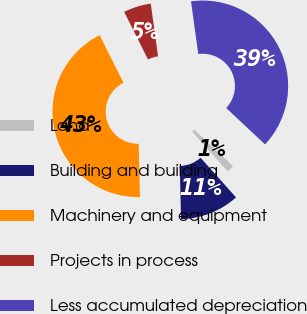<chart> <loc_0><loc_0><loc_500><loc_500><pie_chart><fcel>Land<fcel>Building and building<fcel>Machinery and equipment<fcel>Projects in process<fcel>Less accumulated depreciation<nl><fcel>1.4%<fcel>11.25%<fcel>42.97%<fcel>5.21%<fcel>39.16%<nl></chart> 